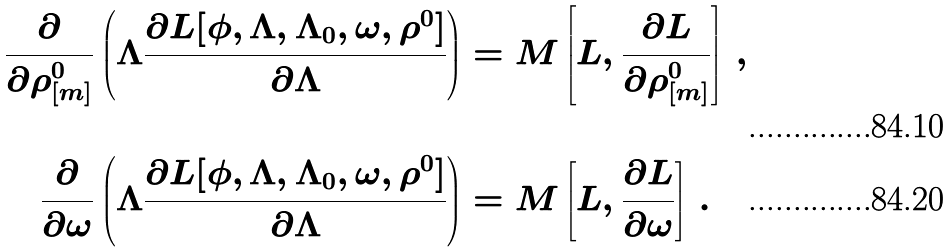Convert formula to latex. <formula><loc_0><loc_0><loc_500><loc_500>\frac { \partial } { \partial \rho _ { [ m ] } ^ { 0 } } \left ( \Lambda \frac { \partial L [ \phi , \Lambda , \Lambda _ { 0 } , \omega , \rho ^ { 0 } ] } { \partial \Lambda } \right ) & = M \left [ L , \frac { \partial L } { \partial \rho _ { [ m ] } ^ { 0 } } \right ] \, , \\ \frac { \partial } { \partial \omega } \left ( \Lambda \frac { \partial L [ \phi , \Lambda , \Lambda _ { 0 } , \omega , \rho ^ { 0 } ] } { \partial \Lambda } \right ) & = M \left [ L , \frac { \partial L } { \partial \omega } \right ] \, .</formula> 